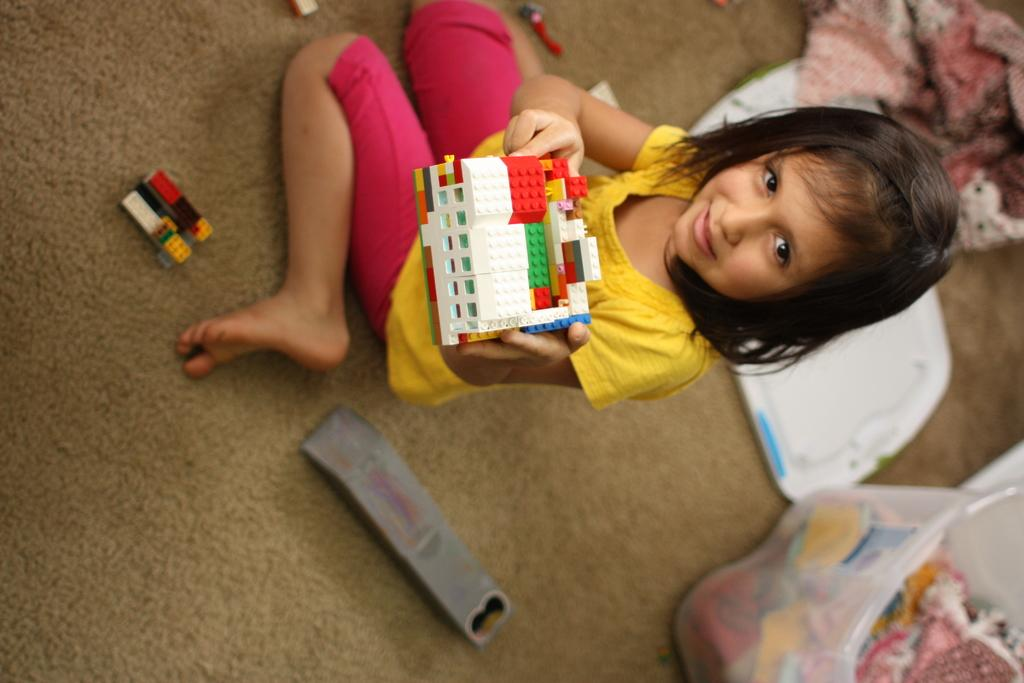Who is the main subject in the image? There is a girl in the image. What is the girl wearing? The girl is wearing a yellow top. What is the girl's facial expression in the image? The girl is smiling. What is the girl holding in the image? The girl is holding a toy. How far away is the book from the girl in the image? There is no book present in the image, so it cannot be determined how far away it is from the girl. 